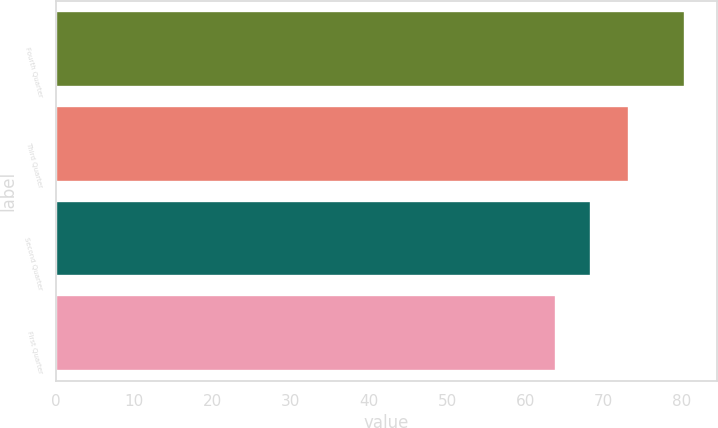Convert chart. <chart><loc_0><loc_0><loc_500><loc_500><bar_chart><fcel>Fourth Quarter<fcel>Third Quarter<fcel>Second Quarter<fcel>First Quarter<nl><fcel>80.44<fcel>73.19<fcel>68.31<fcel>63.84<nl></chart> 